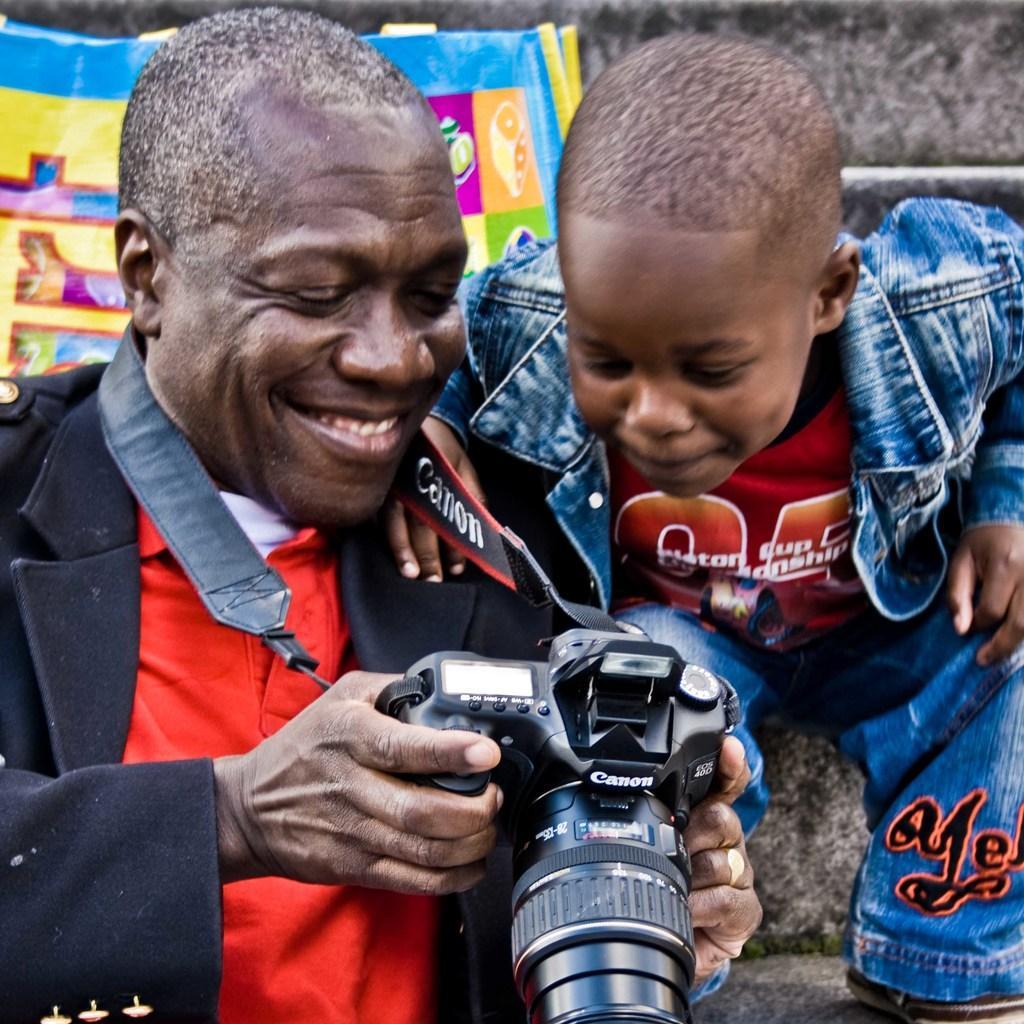In one or two sentences, can you explain what this image depicts? In this image, man and boy was seeing in camera. they both wear colorful dresses. Back Side we can see a banner. 